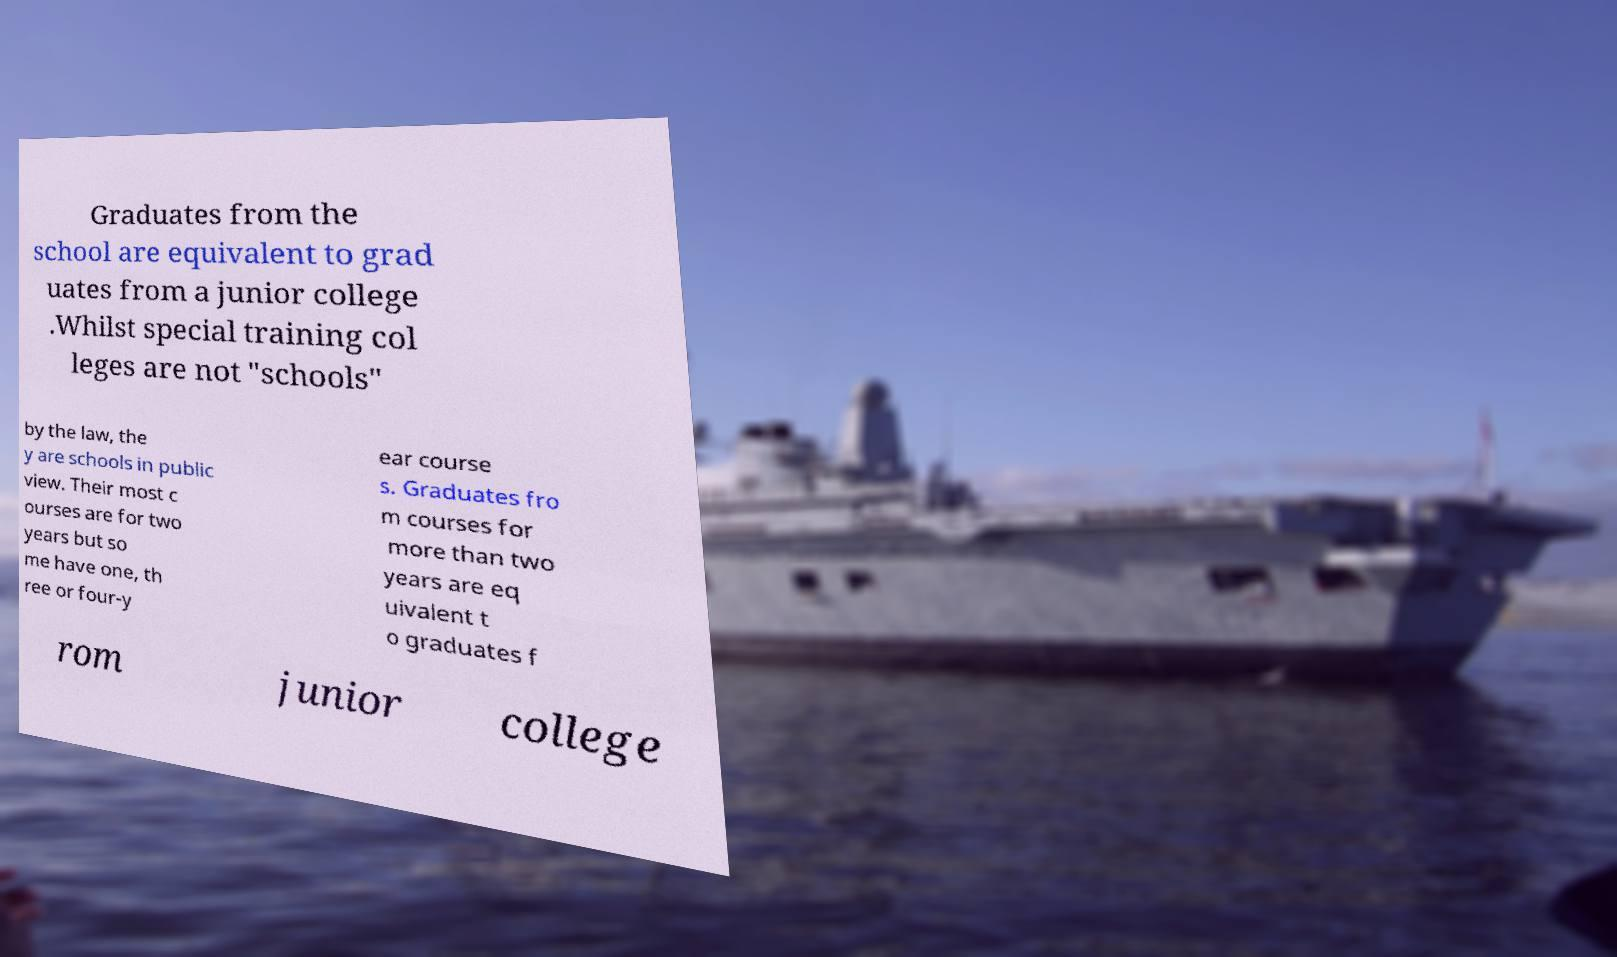There's text embedded in this image that I need extracted. Can you transcribe it verbatim? Graduates from the school are equivalent to grad uates from a junior college .Whilst special training col leges are not "schools" by the law, the y are schools in public view. Their most c ourses are for two years but so me have one, th ree or four-y ear course s. Graduates fro m courses for more than two years are eq uivalent t o graduates f rom junior college 